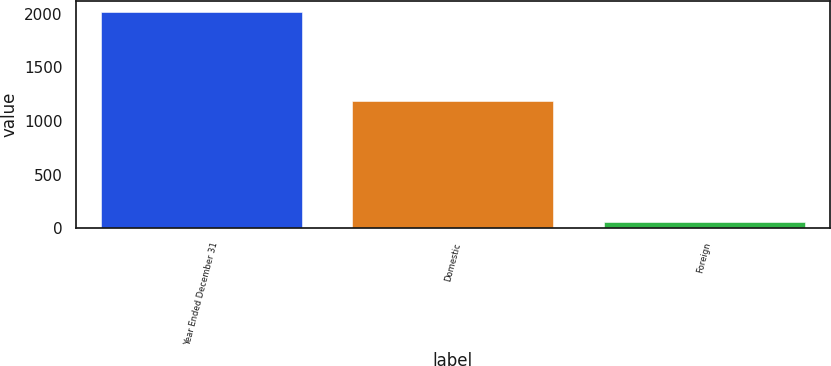<chart> <loc_0><loc_0><loc_500><loc_500><bar_chart><fcel>Year Ended December 31<fcel>Domestic<fcel>Foreign<nl><fcel>2016<fcel>1190.7<fcel>60.3<nl></chart> 